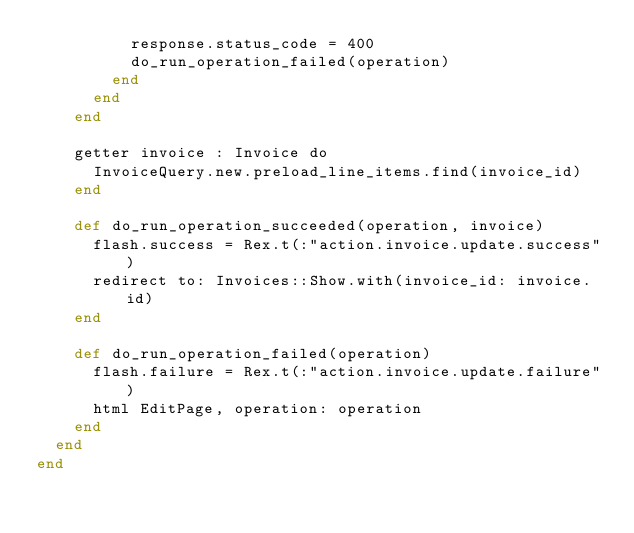<code> <loc_0><loc_0><loc_500><loc_500><_Crystal_>          response.status_code = 400
          do_run_operation_failed(operation)
        end
      end
    end

    getter invoice : Invoice do
      InvoiceQuery.new.preload_line_items.find(invoice_id)
    end

    def do_run_operation_succeeded(operation, invoice)
      flash.success = Rex.t(:"action.invoice.update.success")
      redirect to: Invoices::Show.with(invoice_id: invoice.id)
    end

    def do_run_operation_failed(operation)
      flash.failure = Rex.t(:"action.invoice.update.failure")
      html EditPage, operation: operation
    end
  end
end
</code> 